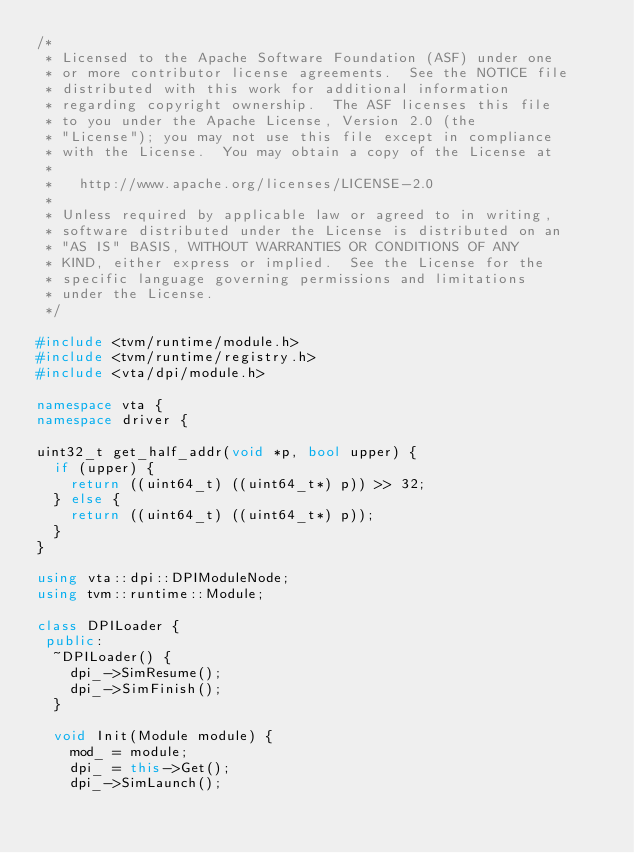Convert code to text. <code><loc_0><loc_0><loc_500><loc_500><_C++_>/*
 * Licensed to the Apache Software Foundation (ASF) under one
 * or more contributor license agreements.  See the NOTICE file
 * distributed with this work for additional information
 * regarding copyright ownership.  The ASF licenses this file
 * to you under the Apache License, Version 2.0 (the
 * "License"); you may not use this file except in compliance
 * with the License.  You may obtain a copy of the License at
 *
 *   http://www.apache.org/licenses/LICENSE-2.0
 *
 * Unless required by applicable law or agreed to in writing,
 * software distributed under the License is distributed on an
 * "AS IS" BASIS, WITHOUT WARRANTIES OR CONDITIONS OF ANY
 * KIND, either express or implied.  See the License for the
 * specific language governing permissions and limitations
 * under the License.
 */

#include <tvm/runtime/module.h>
#include <tvm/runtime/registry.h>
#include <vta/dpi/module.h>

namespace vta {
namespace driver {

uint32_t get_half_addr(void *p, bool upper) {
  if (upper) {
    return ((uint64_t) ((uint64_t*) p)) >> 32;
  } else {
    return ((uint64_t) ((uint64_t*) p));
  }
}

using vta::dpi::DPIModuleNode;
using tvm::runtime::Module;

class DPILoader {
 public:
  ~DPILoader() {
    dpi_->SimResume();
    dpi_->SimFinish();
  }

  void Init(Module module) {
    mod_ = module;
    dpi_ = this->Get();
    dpi_->SimLaunch();</code> 